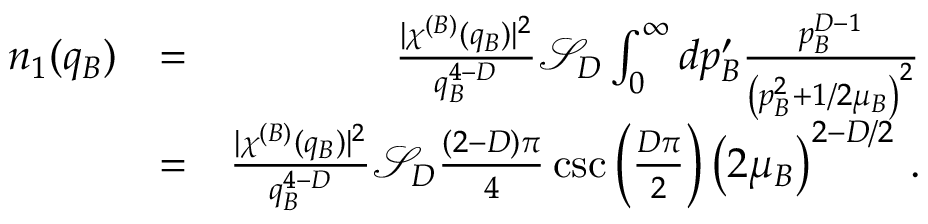<formula> <loc_0><loc_0><loc_500><loc_500>\begin{array} { r l r } { n _ { 1 } ( q _ { B } ) } & { = } & { \frac { | \chi ^ { ( B ) } ( q _ { B } ) | ^ { 2 } } { q _ { B } ^ { 4 - D } } \mathcal { S } _ { D } \int _ { 0 } ^ { \infty } d p _ { B } ^ { \prime } \frac { p _ { B } ^ { D - 1 } } { \left ( p _ { B } ^ { 2 } + 1 / 2 \mu _ { B } \right ) ^ { 2 } } } \\ & { = } & { \frac { | \chi ^ { ( B ) } ( q _ { B } ) | ^ { 2 } } { q _ { B } ^ { 4 - D } } \mathcal { S } _ { D } \frac { ( 2 - D ) \pi } { 4 } \csc \left ( \frac { D \pi } { 2 } \right ) \left ( 2 \mu _ { B } \right ) ^ { 2 - D / 2 } \, . } \end{array}</formula> 